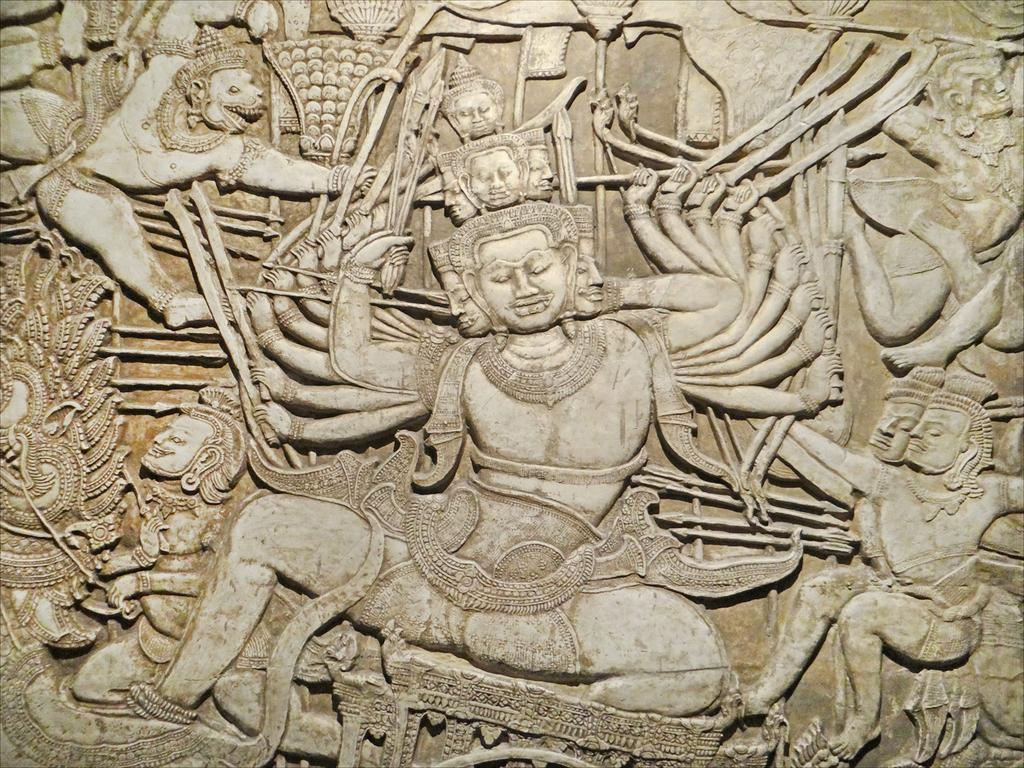What type of art is depicted in the image? There is stone carving in the image. Can you describe the medium used in the art? The medium used in the art is stone. What technique might have been used to create the stone carving? The technique used to create the stone carving could involve chiseling or sculpting the stone. What type of ink is used in the heart-shaped club in the image? There is no ink, heart, or club present in the image; it features a stone carving. 